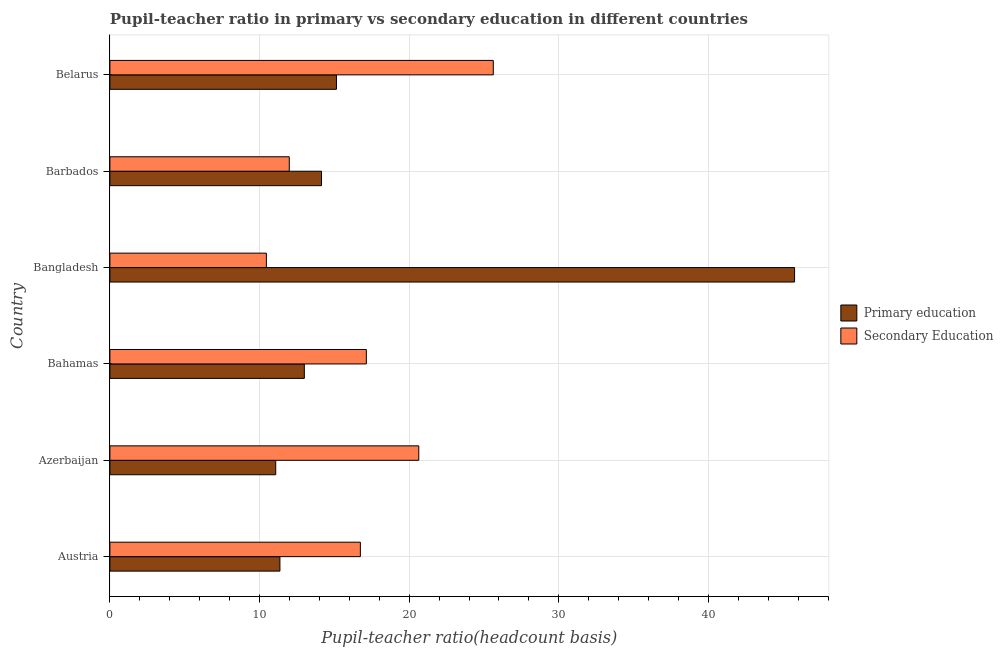How many groups of bars are there?
Offer a very short reply. 6. Are the number of bars on each tick of the Y-axis equal?
Offer a very short reply. Yes. How many bars are there on the 6th tick from the bottom?
Provide a short and direct response. 2. What is the label of the 1st group of bars from the top?
Your response must be concise. Belarus. In how many cases, is the number of bars for a given country not equal to the number of legend labels?
Offer a very short reply. 0. What is the pupil teacher ratio on secondary education in Austria?
Offer a terse response. 16.74. Across all countries, what is the maximum pupil-teacher ratio in primary education?
Make the answer very short. 45.76. Across all countries, what is the minimum pupil teacher ratio on secondary education?
Give a very brief answer. 10.46. In which country was the pupil-teacher ratio in primary education maximum?
Your answer should be compact. Bangladesh. In which country was the pupil-teacher ratio in primary education minimum?
Provide a succinct answer. Azerbaijan. What is the total pupil-teacher ratio in primary education in the graph?
Keep it short and to the point. 110.48. What is the difference between the pupil-teacher ratio in primary education in Austria and that in Barbados?
Provide a succinct answer. -2.78. What is the difference between the pupil teacher ratio on secondary education in Azerbaijan and the pupil-teacher ratio in primary education in Barbados?
Make the answer very short. 6.5. What is the average pupil-teacher ratio in primary education per country?
Make the answer very short. 18.41. What is the difference between the pupil teacher ratio on secondary education and pupil-teacher ratio in primary education in Bahamas?
Ensure brevity in your answer.  4.14. In how many countries, is the pupil-teacher ratio in primary education greater than 14 ?
Offer a terse response. 3. What is the ratio of the pupil-teacher ratio in primary education in Bangladesh to that in Belarus?
Offer a very short reply. 3.02. Is the pupil teacher ratio on secondary education in Azerbaijan less than that in Belarus?
Provide a succinct answer. Yes. Is the difference between the pupil-teacher ratio in primary education in Austria and Barbados greater than the difference between the pupil teacher ratio on secondary education in Austria and Barbados?
Ensure brevity in your answer.  No. What is the difference between the highest and the second highest pupil-teacher ratio in primary education?
Your answer should be very brief. 30.62. What is the difference between the highest and the lowest pupil-teacher ratio in primary education?
Ensure brevity in your answer.  34.68. Is the sum of the pupil-teacher ratio in primary education in Austria and Bangladesh greater than the maximum pupil teacher ratio on secondary education across all countries?
Provide a short and direct response. Yes. What does the 2nd bar from the top in Azerbaijan represents?
Provide a short and direct response. Primary education. What does the 2nd bar from the bottom in Barbados represents?
Make the answer very short. Secondary Education. Are all the bars in the graph horizontal?
Ensure brevity in your answer.  Yes. Are the values on the major ticks of X-axis written in scientific E-notation?
Provide a succinct answer. No. Does the graph contain any zero values?
Provide a short and direct response. No. Where does the legend appear in the graph?
Ensure brevity in your answer.  Center right. How many legend labels are there?
Your response must be concise. 2. What is the title of the graph?
Make the answer very short. Pupil-teacher ratio in primary vs secondary education in different countries. Does "Net National savings" appear as one of the legend labels in the graph?
Make the answer very short. No. What is the label or title of the X-axis?
Make the answer very short. Pupil-teacher ratio(headcount basis). What is the Pupil-teacher ratio(headcount basis) of Primary education in Austria?
Offer a terse response. 11.36. What is the Pupil-teacher ratio(headcount basis) in Secondary Education in Austria?
Your answer should be very brief. 16.74. What is the Pupil-teacher ratio(headcount basis) in Primary education in Azerbaijan?
Your answer should be very brief. 11.08. What is the Pupil-teacher ratio(headcount basis) in Secondary Education in Azerbaijan?
Your answer should be compact. 20.64. What is the Pupil-teacher ratio(headcount basis) of Primary education in Bahamas?
Your response must be concise. 12.99. What is the Pupil-teacher ratio(headcount basis) in Secondary Education in Bahamas?
Your response must be concise. 17.14. What is the Pupil-teacher ratio(headcount basis) of Primary education in Bangladesh?
Give a very brief answer. 45.76. What is the Pupil-teacher ratio(headcount basis) in Secondary Education in Bangladesh?
Give a very brief answer. 10.46. What is the Pupil-teacher ratio(headcount basis) of Primary education in Barbados?
Provide a succinct answer. 14.14. What is the Pupil-teacher ratio(headcount basis) of Secondary Education in Barbados?
Offer a terse response. 11.99. What is the Pupil-teacher ratio(headcount basis) of Primary education in Belarus?
Provide a succinct answer. 15.14. What is the Pupil-teacher ratio(headcount basis) in Secondary Education in Belarus?
Ensure brevity in your answer.  25.62. Across all countries, what is the maximum Pupil-teacher ratio(headcount basis) of Primary education?
Your answer should be very brief. 45.76. Across all countries, what is the maximum Pupil-teacher ratio(headcount basis) in Secondary Education?
Give a very brief answer. 25.62. Across all countries, what is the minimum Pupil-teacher ratio(headcount basis) of Primary education?
Make the answer very short. 11.08. Across all countries, what is the minimum Pupil-teacher ratio(headcount basis) of Secondary Education?
Make the answer very short. 10.46. What is the total Pupil-teacher ratio(headcount basis) in Primary education in the graph?
Give a very brief answer. 110.48. What is the total Pupil-teacher ratio(headcount basis) of Secondary Education in the graph?
Ensure brevity in your answer.  102.59. What is the difference between the Pupil-teacher ratio(headcount basis) in Primary education in Austria and that in Azerbaijan?
Provide a short and direct response. 0.28. What is the difference between the Pupil-teacher ratio(headcount basis) in Secondary Education in Austria and that in Azerbaijan?
Provide a succinct answer. -3.9. What is the difference between the Pupil-teacher ratio(headcount basis) of Primary education in Austria and that in Bahamas?
Make the answer very short. -1.63. What is the difference between the Pupil-teacher ratio(headcount basis) in Secondary Education in Austria and that in Bahamas?
Keep it short and to the point. -0.4. What is the difference between the Pupil-teacher ratio(headcount basis) of Primary education in Austria and that in Bangladesh?
Make the answer very short. -34.4. What is the difference between the Pupil-teacher ratio(headcount basis) of Secondary Education in Austria and that in Bangladesh?
Provide a short and direct response. 6.28. What is the difference between the Pupil-teacher ratio(headcount basis) of Primary education in Austria and that in Barbados?
Provide a succinct answer. -2.78. What is the difference between the Pupil-teacher ratio(headcount basis) of Secondary Education in Austria and that in Barbados?
Keep it short and to the point. 4.75. What is the difference between the Pupil-teacher ratio(headcount basis) of Primary education in Austria and that in Belarus?
Keep it short and to the point. -3.78. What is the difference between the Pupil-teacher ratio(headcount basis) in Secondary Education in Austria and that in Belarus?
Offer a very short reply. -8.88. What is the difference between the Pupil-teacher ratio(headcount basis) of Primary education in Azerbaijan and that in Bahamas?
Ensure brevity in your answer.  -1.91. What is the difference between the Pupil-teacher ratio(headcount basis) of Secondary Education in Azerbaijan and that in Bahamas?
Offer a very short reply. 3.5. What is the difference between the Pupil-teacher ratio(headcount basis) of Primary education in Azerbaijan and that in Bangladesh?
Your answer should be compact. -34.67. What is the difference between the Pupil-teacher ratio(headcount basis) of Secondary Education in Azerbaijan and that in Bangladesh?
Your answer should be compact. 10.19. What is the difference between the Pupil-teacher ratio(headcount basis) in Primary education in Azerbaijan and that in Barbados?
Offer a very short reply. -3.06. What is the difference between the Pupil-teacher ratio(headcount basis) in Secondary Education in Azerbaijan and that in Barbados?
Keep it short and to the point. 8.65. What is the difference between the Pupil-teacher ratio(headcount basis) of Primary education in Azerbaijan and that in Belarus?
Ensure brevity in your answer.  -4.06. What is the difference between the Pupil-teacher ratio(headcount basis) in Secondary Education in Azerbaijan and that in Belarus?
Give a very brief answer. -4.98. What is the difference between the Pupil-teacher ratio(headcount basis) in Primary education in Bahamas and that in Bangladesh?
Keep it short and to the point. -32.76. What is the difference between the Pupil-teacher ratio(headcount basis) of Secondary Education in Bahamas and that in Bangladesh?
Your answer should be compact. 6.68. What is the difference between the Pupil-teacher ratio(headcount basis) in Primary education in Bahamas and that in Barbados?
Your response must be concise. -1.15. What is the difference between the Pupil-teacher ratio(headcount basis) of Secondary Education in Bahamas and that in Barbados?
Offer a very short reply. 5.15. What is the difference between the Pupil-teacher ratio(headcount basis) in Primary education in Bahamas and that in Belarus?
Provide a short and direct response. -2.15. What is the difference between the Pupil-teacher ratio(headcount basis) of Secondary Education in Bahamas and that in Belarus?
Ensure brevity in your answer.  -8.48. What is the difference between the Pupil-teacher ratio(headcount basis) in Primary education in Bangladesh and that in Barbados?
Your response must be concise. 31.62. What is the difference between the Pupil-teacher ratio(headcount basis) of Secondary Education in Bangladesh and that in Barbados?
Give a very brief answer. -1.53. What is the difference between the Pupil-teacher ratio(headcount basis) in Primary education in Bangladesh and that in Belarus?
Your answer should be very brief. 30.62. What is the difference between the Pupil-teacher ratio(headcount basis) of Secondary Education in Bangladesh and that in Belarus?
Your response must be concise. -15.17. What is the difference between the Pupil-teacher ratio(headcount basis) in Primary education in Barbados and that in Belarus?
Offer a very short reply. -1. What is the difference between the Pupil-teacher ratio(headcount basis) in Secondary Education in Barbados and that in Belarus?
Provide a succinct answer. -13.63. What is the difference between the Pupil-teacher ratio(headcount basis) of Primary education in Austria and the Pupil-teacher ratio(headcount basis) of Secondary Education in Azerbaijan?
Your response must be concise. -9.28. What is the difference between the Pupil-teacher ratio(headcount basis) of Primary education in Austria and the Pupil-teacher ratio(headcount basis) of Secondary Education in Bahamas?
Your response must be concise. -5.78. What is the difference between the Pupil-teacher ratio(headcount basis) of Primary education in Austria and the Pupil-teacher ratio(headcount basis) of Secondary Education in Bangladesh?
Provide a succinct answer. 0.9. What is the difference between the Pupil-teacher ratio(headcount basis) in Primary education in Austria and the Pupil-teacher ratio(headcount basis) in Secondary Education in Barbados?
Offer a very short reply. -0.63. What is the difference between the Pupil-teacher ratio(headcount basis) in Primary education in Austria and the Pupil-teacher ratio(headcount basis) in Secondary Education in Belarus?
Make the answer very short. -14.26. What is the difference between the Pupil-teacher ratio(headcount basis) of Primary education in Azerbaijan and the Pupil-teacher ratio(headcount basis) of Secondary Education in Bahamas?
Provide a short and direct response. -6.06. What is the difference between the Pupil-teacher ratio(headcount basis) in Primary education in Azerbaijan and the Pupil-teacher ratio(headcount basis) in Secondary Education in Bangladesh?
Your answer should be compact. 0.62. What is the difference between the Pupil-teacher ratio(headcount basis) of Primary education in Azerbaijan and the Pupil-teacher ratio(headcount basis) of Secondary Education in Barbados?
Your response must be concise. -0.91. What is the difference between the Pupil-teacher ratio(headcount basis) of Primary education in Azerbaijan and the Pupil-teacher ratio(headcount basis) of Secondary Education in Belarus?
Your answer should be compact. -14.54. What is the difference between the Pupil-teacher ratio(headcount basis) in Primary education in Bahamas and the Pupil-teacher ratio(headcount basis) in Secondary Education in Bangladesh?
Provide a short and direct response. 2.54. What is the difference between the Pupil-teacher ratio(headcount basis) in Primary education in Bahamas and the Pupil-teacher ratio(headcount basis) in Secondary Education in Barbados?
Your answer should be compact. 1.01. What is the difference between the Pupil-teacher ratio(headcount basis) of Primary education in Bahamas and the Pupil-teacher ratio(headcount basis) of Secondary Education in Belarus?
Your response must be concise. -12.63. What is the difference between the Pupil-teacher ratio(headcount basis) of Primary education in Bangladesh and the Pupil-teacher ratio(headcount basis) of Secondary Education in Barbados?
Provide a short and direct response. 33.77. What is the difference between the Pupil-teacher ratio(headcount basis) of Primary education in Bangladesh and the Pupil-teacher ratio(headcount basis) of Secondary Education in Belarus?
Your answer should be very brief. 20.13. What is the difference between the Pupil-teacher ratio(headcount basis) in Primary education in Barbados and the Pupil-teacher ratio(headcount basis) in Secondary Education in Belarus?
Give a very brief answer. -11.48. What is the average Pupil-teacher ratio(headcount basis) in Primary education per country?
Your answer should be compact. 18.41. What is the average Pupil-teacher ratio(headcount basis) in Secondary Education per country?
Make the answer very short. 17.1. What is the difference between the Pupil-teacher ratio(headcount basis) in Primary education and Pupil-teacher ratio(headcount basis) in Secondary Education in Austria?
Provide a short and direct response. -5.38. What is the difference between the Pupil-teacher ratio(headcount basis) in Primary education and Pupil-teacher ratio(headcount basis) in Secondary Education in Azerbaijan?
Provide a succinct answer. -9.56. What is the difference between the Pupil-teacher ratio(headcount basis) in Primary education and Pupil-teacher ratio(headcount basis) in Secondary Education in Bahamas?
Give a very brief answer. -4.14. What is the difference between the Pupil-teacher ratio(headcount basis) in Primary education and Pupil-teacher ratio(headcount basis) in Secondary Education in Bangladesh?
Give a very brief answer. 35.3. What is the difference between the Pupil-teacher ratio(headcount basis) of Primary education and Pupil-teacher ratio(headcount basis) of Secondary Education in Barbados?
Offer a terse response. 2.15. What is the difference between the Pupil-teacher ratio(headcount basis) of Primary education and Pupil-teacher ratio(headcount basis) of Secondary Education in Belarus?
Offer a terse response. -10.48. What is the ratio of the Pupil-teacher ratio(headcount basis) of Primary education in Austria to that in Azerbaijan?
Ensure brevity in your answer.  1.03. What is the ratio of the Pupil-teacher ratio(headcount basis) in Secondary Education in Austria to that in Azerbaijan?
Your answer should be very brief. 0.81. What is the ratio of the Pupil-teacher ratio(headcount basis) of Primary education in Austria to that in Bahamas?
Your answer should be very brief. 0.87. What is the ratio of the Pupil-teacher ratio(headcount basis) in Secondary Education in Austria to that in Bahamas?
Offer a very short reply. 0.98. What is the ratio of the Pupil-teacher ratio(headcount basis) of Primary education in Austria to that in Bangladesh?
Your answer should be very brief. 0.25. What is the ratio of the Pupil-teacher ratio(headcount basis) of Secondary Education in Austria to that in Bangladesh?
Your answer should be compact. 1.6. What is the ratio of the Pupil-teacher ratio(headcount basis) in Primary education in Austria to that in Barbados?
Your answer should be compact. 0.8. What is the ratio of the Pupil-teacher ratio(headcount basis) of Secondary Education in Austria to that in Barbados?
Offer a very short reply. 1.4. What is the ratio of the Pupil-teacher ratio(headcount basis) of Primary education in Austria to that in Belarus?
Offer a terse response. 0.75. What is the ratio of the Pupil-teacher ratio(headcount basis) in Secondary Education in Austria to that in Belarus?
Offer a terse response. 0.65. What is the ratio of the Pupil-teacher ratio(headcount basis) of Primary education in Azerbaijan to that in Bahamas?
Provide a short and direct response. 0.85. What is the ratio of the Pupil-teacher ratio(headcount basis) of Secondary Education in Azerbaijan to that in Bahamas?
Make the answer very short. 1.2. What is the ratio of the Pupil-teacher ratio(headcount basis) in Primary education in Azerbaijan to that in Bangladesh?
Offer a terse response. 0.24. What is the ratio of the Pupil-teacher ratio(headcount basis) of Secondary Education in Azerbaijan to that in Bangladesh?
Give a very brief answer. 1.97. What is the ratio of the Pupil-teacher ratio(headcount basis) in Primary education in Azerbaijan to that in Barbados?
Provide a succinct answer. 0.78. What is the ratio of the Pupil-teacher ratio(headcount basis) of Secondary Education in Azerbaijan to that in Barbados?
Offer a terse response. 1.72. What is the ratio of the Pupil-teacher ratio(headcount basis) of Primary education in Azerbaijan to that in Belarus?
Your response must be concise. 0.73. What is the ratio of the Pupil-teacher ratio(headcount basis) of Secondary Education in Azerbaijan to that in Belarus?
Keep it short and to the point. 0.81. What is the ratio of the Pupil-teacher ratio(headcount basis) of Primary education in Bahamas to that in Bangladesh?
Provide a succinct answer. 0.28. What is the ratio of the Pupil-teacher ratio(headcount basis) in Secondary Education in Bahamas to that in Bangladesh?
Provide a short and direct response. 1.64. What is the ratio of the Pupil-teacher ratio(headcount basis) in Primary education in Bahamas to that in Barbados?
Make the answer very short. 0.92. What is the ratio of the Pupil-teacher ratio(headcount basis) of Secondary Education in Bahamas to that in Barbados?
Offer a very short reply. 1.43. What is the ratio of the Pupil-teacher ratio(headcount basis) of Primary education in Bahamas to that in Belarus?
Your answer should be compact. 0.86. What is the ratio of the Pupil-teacher ratio(headcount basis) of Secondary Education in Bahamas to that in Belarus?
Your response must be concise. 0.67. What is the ratio of the Pupil-teacher ratio(headcount basis) of Primary education in Bangladesh to that in Barbados?
Your answer should be very brief. 3.24. What is the ratio of the Pupil-teacher ratio(headcount basis) in Secondary Education in Bangladesh to that in Barbados?
Keep it short and to the point. 0.87. What is the ratio of the Pupil-teacher ratio(headcount basis) of Primary education in Bangladesh to that in Belarus?
Provide a succinct answer. 3.02. What is the ratio of the Pupil-teacher ratio(headcount basis) of Secondary Education in Bangladesh to that in Belarus?
Your response must be concise. 0.41. What is the ratio of the Pupil-teacher ratio(headcount basis) in Primary education in Barbados to that in Belarus?
Ensure brevity in your answer.  0.93. What is the ratio of the Pupil-teacher ratio(headcount basis) of Secondary Education in Barbados to that in Belarus?
Provide a short and direct response. 0.47. What is the difference between the highest and the second highest Pupil-teacher ratio(headcount basis) in Primary education?
Offer a terse response. 30.62. What is the difference between the highest and the second highest Pupil-teacher ratio(headcount basis) of Secondary Education?
Ensure brevity in your answer.  4.98. What is the difference between the highest and the lowest Pupil-teacher ratio(headcount basis) of Primary education?
Provide a short and direct response. 34.67. What is the difference between the highest and the lowest Pupil-teacher ratio(headcount basis) in Secondary Education?
Make the answer very short. 15.17. 